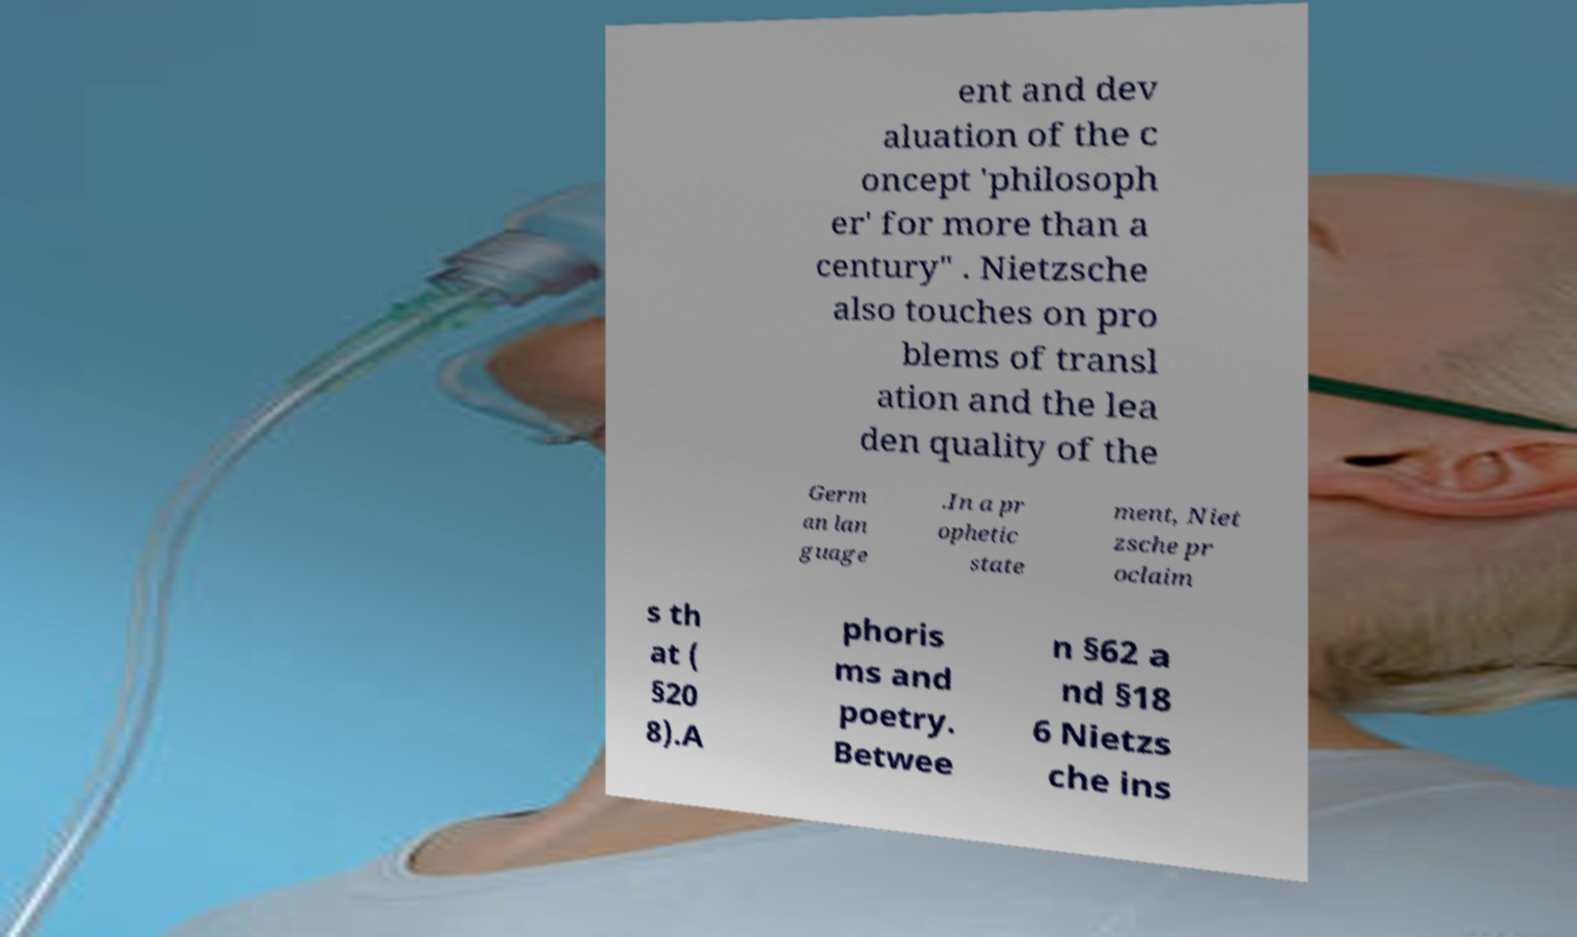What messages or text are displayed in this image? I need them in a readable, typed format. ent and dev aluation of the c oncept 'philosoph er' for more than a century" . Nietzsche also touches on pro blems of transl ation and the lea den quality of the Germ an lan guage .In a pr ophetic state ment, Niet zsche pr oclaim s th at ( §20 8).A phoris ms and poetry. Betwee n §62 a nd §18 6 Nietzs che ins 